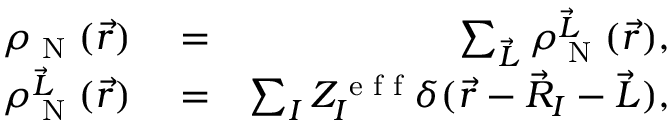Convert formula to latex. <formula><loc_0><loc_0><loc_500><loc_500>\begin{array} { r l r } { \rho _ { N } ( \vec { r } ) } & = } & { \sum _ { \vec { L } } \rho _ { N } ^ { \vec { L } } ( \vec { r } ) , } \\ { \rho _ { N } ^ { \vec { L } } ( \vec { r } ) } & = } & { \sum _ { I } Z _ { I } ^ { e f f } \delta ( \vec { r } - \vec { R } _ { I } - \vec { L } ) , } \end{array}</formula> 